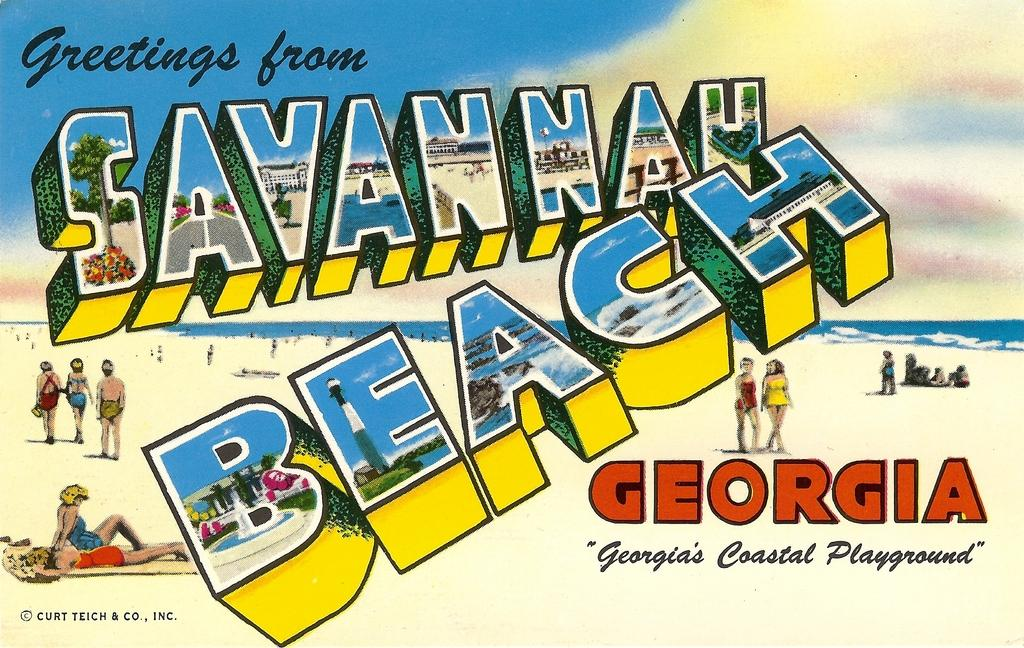Provide a one-sentence caption for the provided image. A postcard from Savannah Beach Georgia with various cartoon like people walking on a beach. 